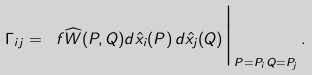Convert formula to latex. <formula><loc_0><loc_0><loc_500><loc_500>\Gamma _ { i j } = \ f { \widehat { W } ( P , Q ) } { d \hat { x } _ { i } ( P ) \, d \hat { x } _ { j } ( Q ) } \Big | _ { P = P _ { i } \, Q = P _ { j } } \, .</formula> 